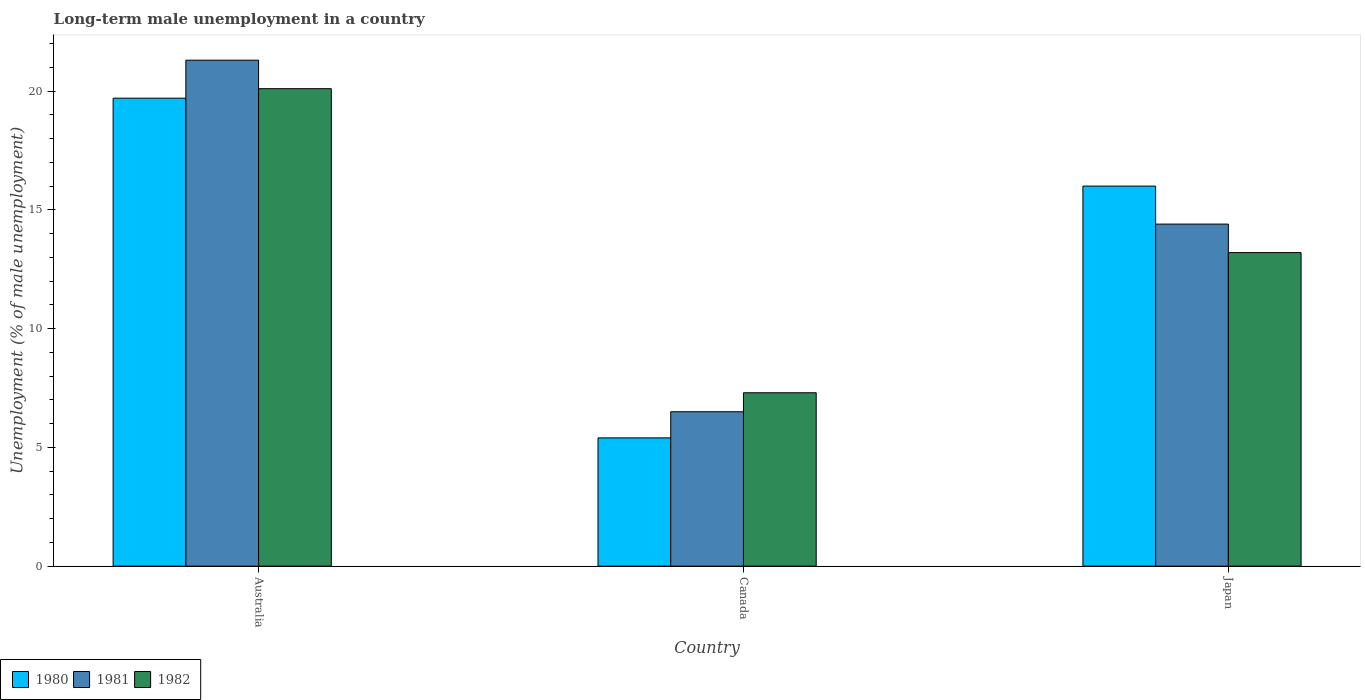Are the number of bars per tick equal to the number of legend labels?
Keep it short and to the point. Yes. How many bars are there on the 1st tick from the right?
Your answer should be compact. 3. What is the label of the 2nd group of bars from the left?
Offer a terse response. Canada. What is the percentage of long-term unemployed male population in 1982 in Australia?
Offer a very short reply. 20.1. Across all countries, what is the maximum percentage of long-term unemployed male population in 1980?
Give a very brief answer. 19.7. Across all countries, what is the minimum percentage of long-term unemployed male population in 1982?
Offer a terse response. 7.3. In which country was the percentage of long-term unemployed male population in 1981 maximum?
Offer a terse response. Australia. What is the total percentage of long-term unemployed male population in 1981 in the graph?
Your response must be concise. 42.2. What is the difference between the percentage of long-term unemployed male population in 1982 in Australia and that in Canada?
Your answer should be compact. 12.8. What is the difference between the percentage of long-term unemployed male population in 1981 in Japan and the percentage of long-term unemployed male population in 1982 in Australia?
Ensure brevity in your answer.  -5.7. What is the average percentage of long-term unemployed male population in 1981 per country?
Keep it short and to the point. 14.07. What is the difference between the percentage of long-term unemployed male population of/in 1982 and percentage of long-term unemployed male population of/in 1980 in Japan?
Your answer should be compact. -2.8. In how many countries, is the percentage of long-term unemployed male population in 1981 greater than 20 %?
Make the answer very short. 1. What is the ratio of the percentage of long-term unemployed male population in 1981 in Australia to that in Japan?
Offer a terse response. 1.48. Is the difference between the percentage of long-term unemployed male population in 1982 in Australia and Japan greater than the difference between the percentage of long-term unemployed male population in 1980 in Australia and Japan?
Ensure brevity in your answer.  Yes. What is the difference between the highest and the second highest percentage of long-term unemployed male population in 1982?
Provide a short and direct response. 6.9. What is the difference between the highest and the lowest percentage of long-term unemployed male population in 1980?
Your answer should be compact. 14.3. Is the sum of the percentage of long-term unemployed male population in 1981 in Australia and Canada greater than the maximum percentage of long-term unemployed male population in 1982 across all countries?
Provide a succinct answer. Yes. What does the 2nd bar from the left in Canada represents?
Your answer should be compact. 1981. Is it the case that in every country, the sum of the percentage of long-term unemployed male population in 1980 and percentage of long-term unemployed male population in 1982 is greater than the percentage of long-term unemployed male population in 1981?
Provide a succinct answer. Yes. How many bars are there?
Offer a terse response. 9. Are all the bars in the graph horizontal?
Offer a terse response. No. Does the graph contain any zero values?
Ensure brevity in your answer.  No. Does the graph contain grids?
Offer a very short reply. No. Where does the legend appear in the graph?
Your answer should be very brief. Bottom left. How are the legend labels stacked?
Provide a short and direct response. Horizontal. What is the title of the graph?
Provide a succinct answer. Long-term male unemployment in a country. What is the label or title of the Y-axis?
Ensure brevity in your answer.  Unemployment (% of male unemployment). What is the Unemployment (% of male unemployment) of 1980 in Australia?
Make the answer very short. 19.7. What is the Unemployment (% of male unemployment) in 1981 in Australia?
Provide a succinct answer. 21.3. What is the Unemployment (% of male unemployment) in 1982 in Australia?
Offer a very short reply. 20.1. What is the Unemployment (% of male unemployment) in 1980 in Canada?
Ensure brevity in your answer.  5.4. What is the Unemployment (% of male unemployment) of 1981 in Canada?
Your response must be concise. 6.5. What is the Unemployment (% of male unemployment) of 1982 in Canada?
Provide a short and direct response. 7.3. What is the Unemployment (% of male unemployment) of 1981 in Japan?
Keep it short and to the point. 14.4. What is the Unemployment (% of male unemployment) of 1982 in Japan?
Keep it short and to the point. 13.2. Across all countries, what is the maximum Unemployment (% of male unemployment) in 1980?
Give a very brief answer. 19.7. Across all countries, what is the maximum Unemployment (% of male unemployment) of 1981?
Your answer should be very brief. 21.3. Across all countries, what is the maximum Unemployment (% of male unemployment) of 1982?
Offer a terse response. 20.1. Across all countries, what is the minimum Unemployment (% of male unemployment) in 1980?
Your answer should be compact. 5.4. Across all countries, what is the minimum Unemployment (% of male unemployment) in 1982?
Your answer should be very brief. 7.3. What is the total Unemployment (% of male unemployment) in 1980 in the graph?
Provide a succinct answer. 41.1. What is the total Unemployment (% of male unemployment) of 1981 in the graph?
Provide a short and direct response. 42.2. What is the total Unemployment (% of male unemployment) in 1982 in the graph?
Your response must be concise. 40.6. What is the difference between the Unemployment (% of male unemployment) of 1980 in Australia and that in Canada?
Offer a very short reply. 14.3. What is the difference between the Unemployment (% of male unemployment) of 1981 in Australia and that in Canada?
Keep it short and to the point. 14.8. What is the difference between the Unemployment (% of male unemployment) of 1980 in Australia and that in Japan?
Keep it short and to the point. 3.7. What is the difference between the Unemployment (% of male unemployment) in 1981 in Australia and that in Japan?
Your response must be concise. 6.9. What is the difference between the Unemployment (% of male unemployment) of 1982 in Australia and that in Japan?
Offer a very short reply. 6.9. What is the difference between the Unemployment (% of male unemployment) of 1980 in Canada and that in Japan?
Keep it short and to the point. -10.6. What is the difference between the Unemployment (% of male unemployment) in 1982 in Canada and that in Japan?
Ensure brevity in your answer.  -5.9. What is the difference between the Unemployment (% of male unemployment) in 1980 in Australia and the Unemployment (% of male unemployment) in 1981 in Canada?
Keep it short and to the point. 13.2. What is the difference between the Unemployment (% of male unemployment) in 1980 in Australia and the Unemployment (% of male unemployment) in 1982 in Canada?
Your answer should be very brief. 12.4. What is the difference between the Unemployment (% of male unemployment) in 1981 in Australia and the Unemployment (% of male unemployment) in 1982 in Canada?
Provide a short and direct response. 14. What is the difference between the Unemployment (% of male unemployment) in 1980 in Australia and the Unemployment (% of male unemployment) in 1981 in Japan?
Make the answer very short. 5.3. What is the difference between the Unemployment (% of male unemployment) in 1980 in Australia and the Unemployment (% of male unemployment) in 1982 in Japan?
Offer a very short reply. 6.5. What is the difference between the Unemployment (% of male unemployment) of 1981 in Australia and the Unemployment (% of male unemployment) of 1982 in Japan?
Your answer should be compact. 8.1. What is the difference between the Unemployment (% of male unemployment) in 1980 in Canada and the Unemployment (% of male unemployment) in 1981 in Japan?
Provide a succinct answer. -9. What is the difference between the Unemployment (% of male unemployment) of 1981 in Canada and the Unemployment (% of male unemployment) of 1982 in Japan?
Ensure brevity in your answer.  -6.7. What is the average Unemployment (% of male unemployment) of 1980 per country?
Offer a very short reply. 13.7. What is the average Unemployment (% of male unemployment) in 1981 per country?
Offer a terse response. 14.07. What is the average Unemployment (% of male unemployment) in 1982 per country?
Provide a succinct answer. 13.53. What is the difference between the Unemployment (% of male unemployment) in 1980 and Unemployment (% of male unemployment) in 1982 in Australia?
Ensure brevity in your answer.  -0.4. What is the difference between the Unemployment (% of male unemployment) in 1981 and Unemployment (% of male unemployment) in 1982 in Australia?
Ensure brevity in your answer.  1.2. What is the difference between the Unemployment (% of male unemployment) of 1981 and Unemployment (% of male unemployment) of 1982 in Canada?
Give a very brief answer. -0.8. What is the difference between the Unemployment (% of male unemployment) of 1980 and Unemployment (% of male unemployment) of 1981 in Japan?
Your response must be concise. 1.6. What is the difference between the Unemployment (% of male unemployment) in 1981 and Unemployment (% of male unemployment) in 1982 in Japan?
Your answer should be very brief. 1.2. What is the ratio of the Unemployment (% of male unemployment) of 1980 in Australia to that in Canada?
Provide a succinct answer. 3.65. What is the ratio of the Unemployment (% of male unemployment) of 1981 in Australia to that in Canada?
Provide a short and direct response. 3.28. What is the ratio of the Unemployment (% of male unemployment) of 1982 in Australia to that in Canada?
Offer a very short reply. 2.75. What is the ratio of the Unemployment (% of male unemployment) in 1980 in Australia to that in Japan?
Your answer should be very brief. 1.23. What is the ratio of the Unemployment (% of male unemployment) in 1981 in Australia to that in Japan?
Provide a short and direct response. 1.48. What is the ratio of the Unemployment (% of male unemployment) of 1982 in Australia to that in Japan?
Your answer should be very brief. 1.52. What is the ratio of the Unemployment (% of male unemployment) in 1980 in Canada to that in Japan?
Your answer should be compact. 0.34. What is the ratio of the Unemployment (% of male unemployment) in 1981 in Canada to that in Japan?
Provide a short and direct response. 0.45. What is the ratio of the Unemployment (% of male unemployment) in 1982 in Canada to that in Japan?
Keep it short and to the point. 0.55. What is the difference between the highest and the second highest Unemployment (% of male unemployment) in 1980?
Make the answer very short. 3.7. What is the difference between the highest and the lowest Unemployment (% of male unemployment) of 1981?
Your response must be concise. 14.8. What is the difference between the highest and the lowest Unemployment (% of male unemployment) of 1982?
Ensure brevity in your answer.  12.8. 